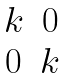<formula> <loc_0><loc_0><loc_500><loc_500>\begin{matrix} k & 0 \\ 0 & k \\ \end{matrix}</formula> 